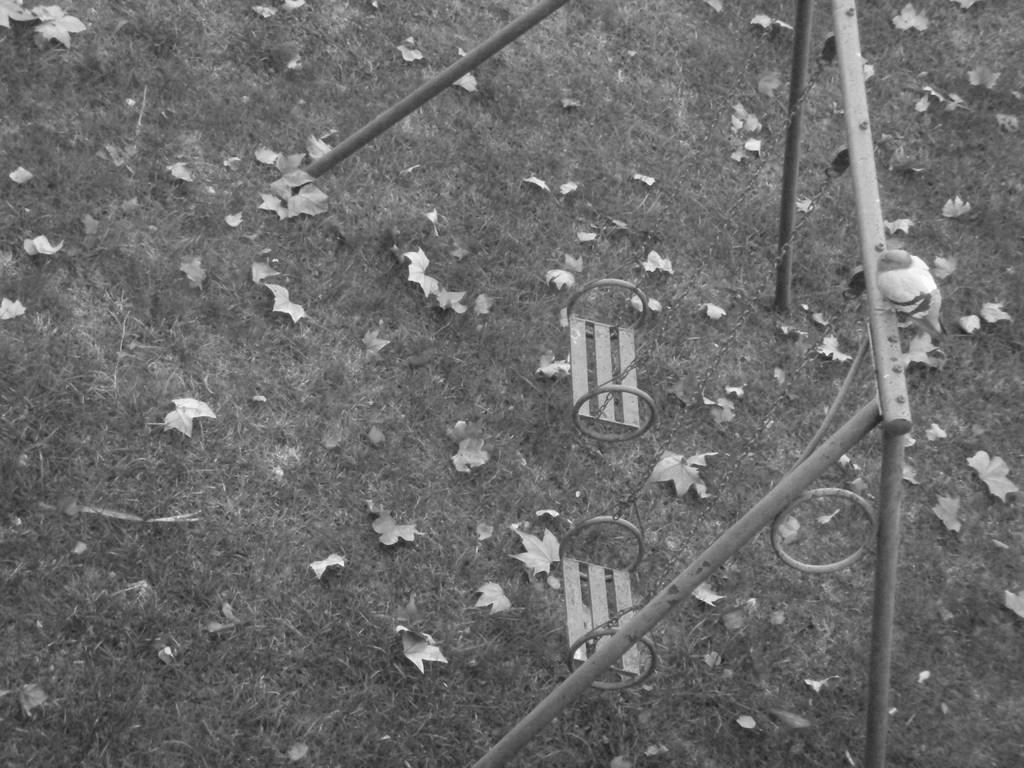What type of playground equipment is present in the image? There are swings in the image. What can be seen on the ground in the image? There are leaves on the grassland in the image. What is the main feature of the landscape in the image? The grassland is visible in the image. How many kitties are playing on the swings in the image? There are no kitties present in the image; it only features swings and leaves on the grassland. What type of mask is being worn by the person on the swing? There is no person or mask visible in the image. 